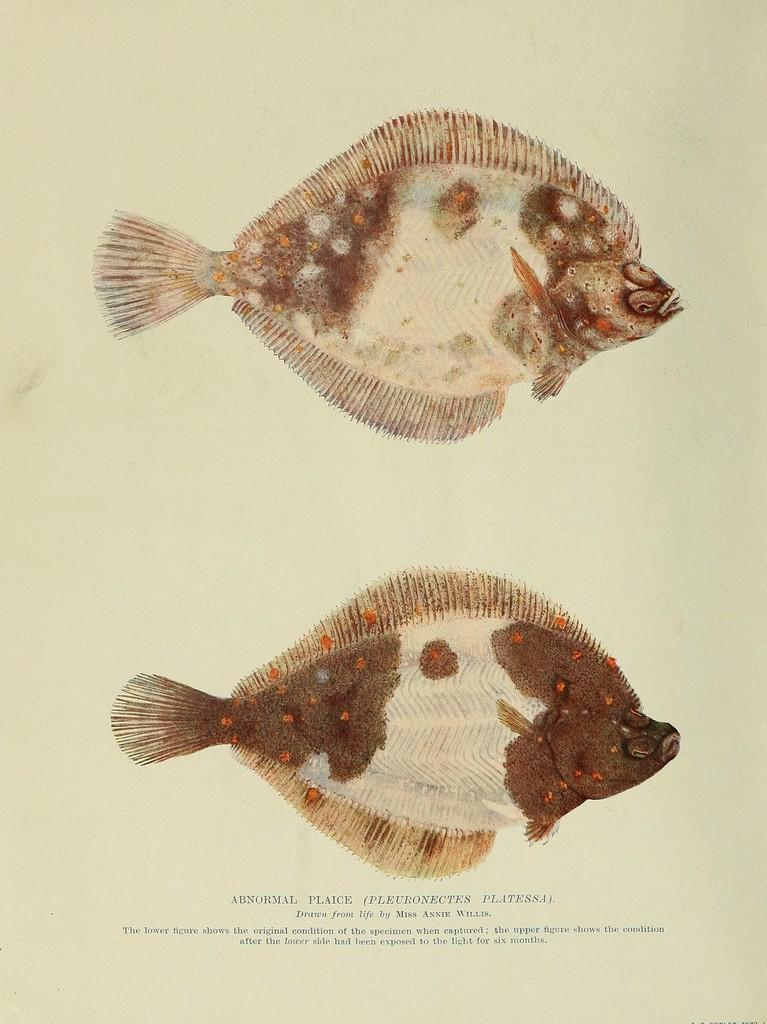What is featured in the image? There is a poster in the image. What can be seen on the poster? The poster contains pictures of fishes. Is there any text on the poster? Yes, there is text written on the poster. What type of watch is being delivered in the parcel shown in the image? There is no watch or parcel present in the image; it only features a poster with pictures of fishes and text. 